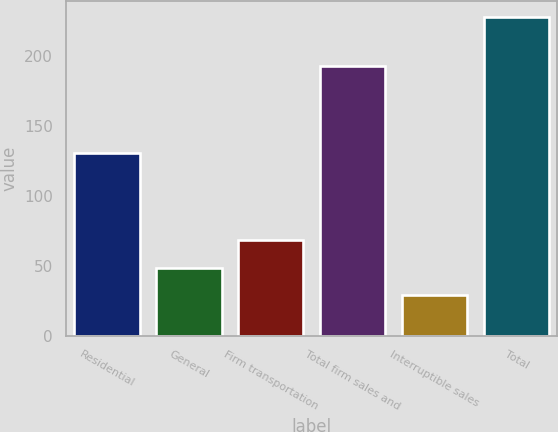Convert chart to OTSL. <chart><loc_0><loc_0><loc_500><loc_500><bar_chart><fcel>Residential<fcel>General<fcel>Firm transportation<fcel>Total firm sales and<fcel>Interruptible sales<fcel>Total<nl><fcel>131<fcel>48.9<fcel>68.8<fcel>193<fcel>29<fcel>228<nl></chart> 